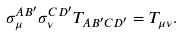<formula> <loc_0><loc_0><loc_500><loc_500>\sigma _ { \mu } ^ { A B ^ { \prime } } \sigma _ { \nu } ^ { C D ^ { \prime } } T _ { A B ^ { \prime } C D ^ { \prime } } = T _ { \mu \nu } .</formula> 